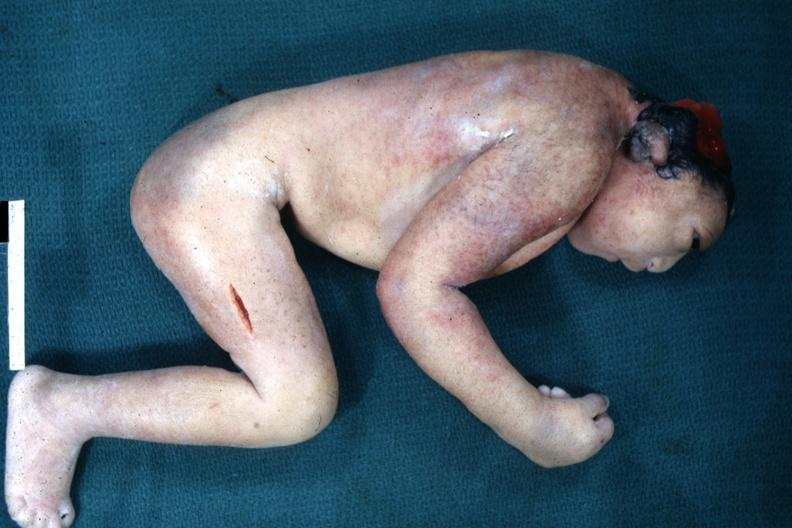what does this image show?
Answer the question using a single word or phrase. Lateral view of typical appearance 